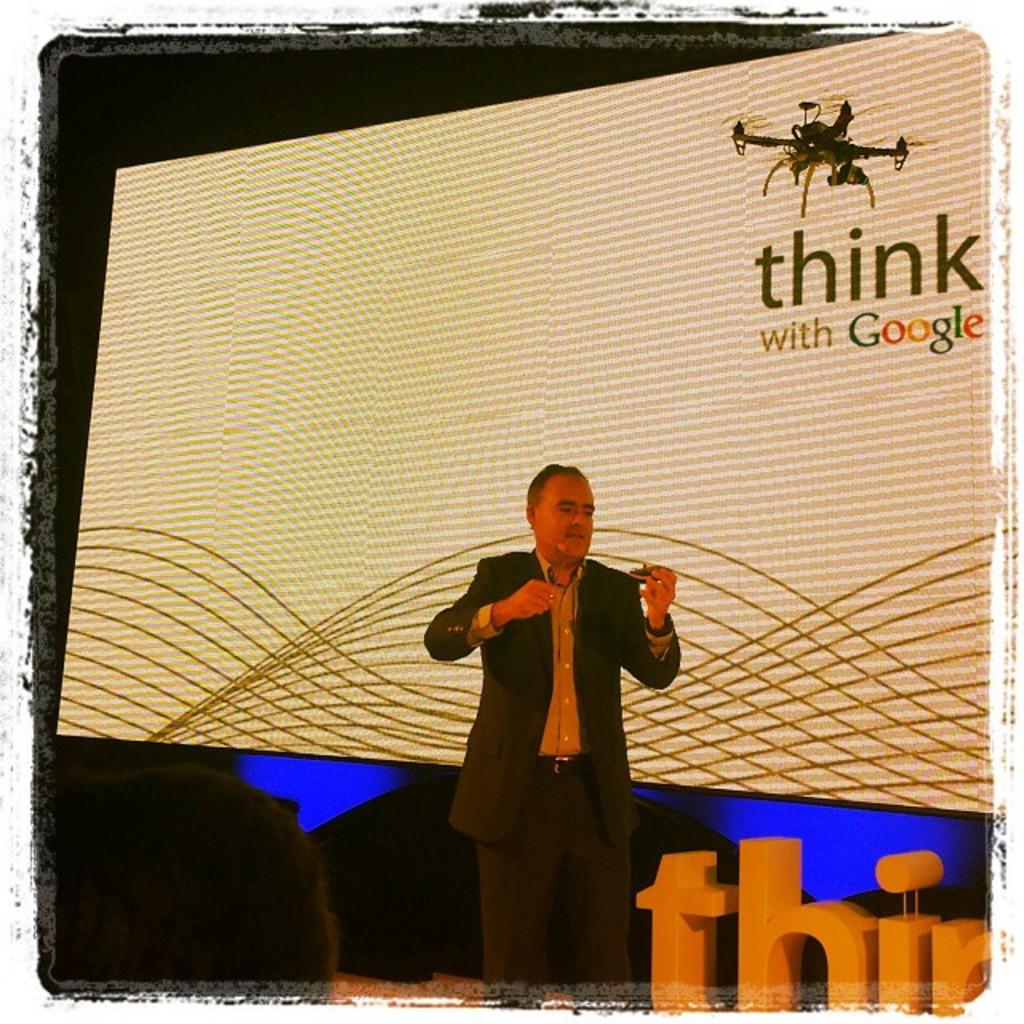What is the man in the image doing? The man is standing and talking. What can be seen behind the man? There is a screen behind the man. Can you describe the person on the left side of the image? Only the head of a person is visible on the left side of the image. How would you describe the overall lighting in the image? The background of the image is dark. What type of battle is taking place in the image? There is no battle present in the image; it features a man standing and talking with a screen behind him. Can you tell me how many kitties are visible in the image? There are no kitties present in the image. 